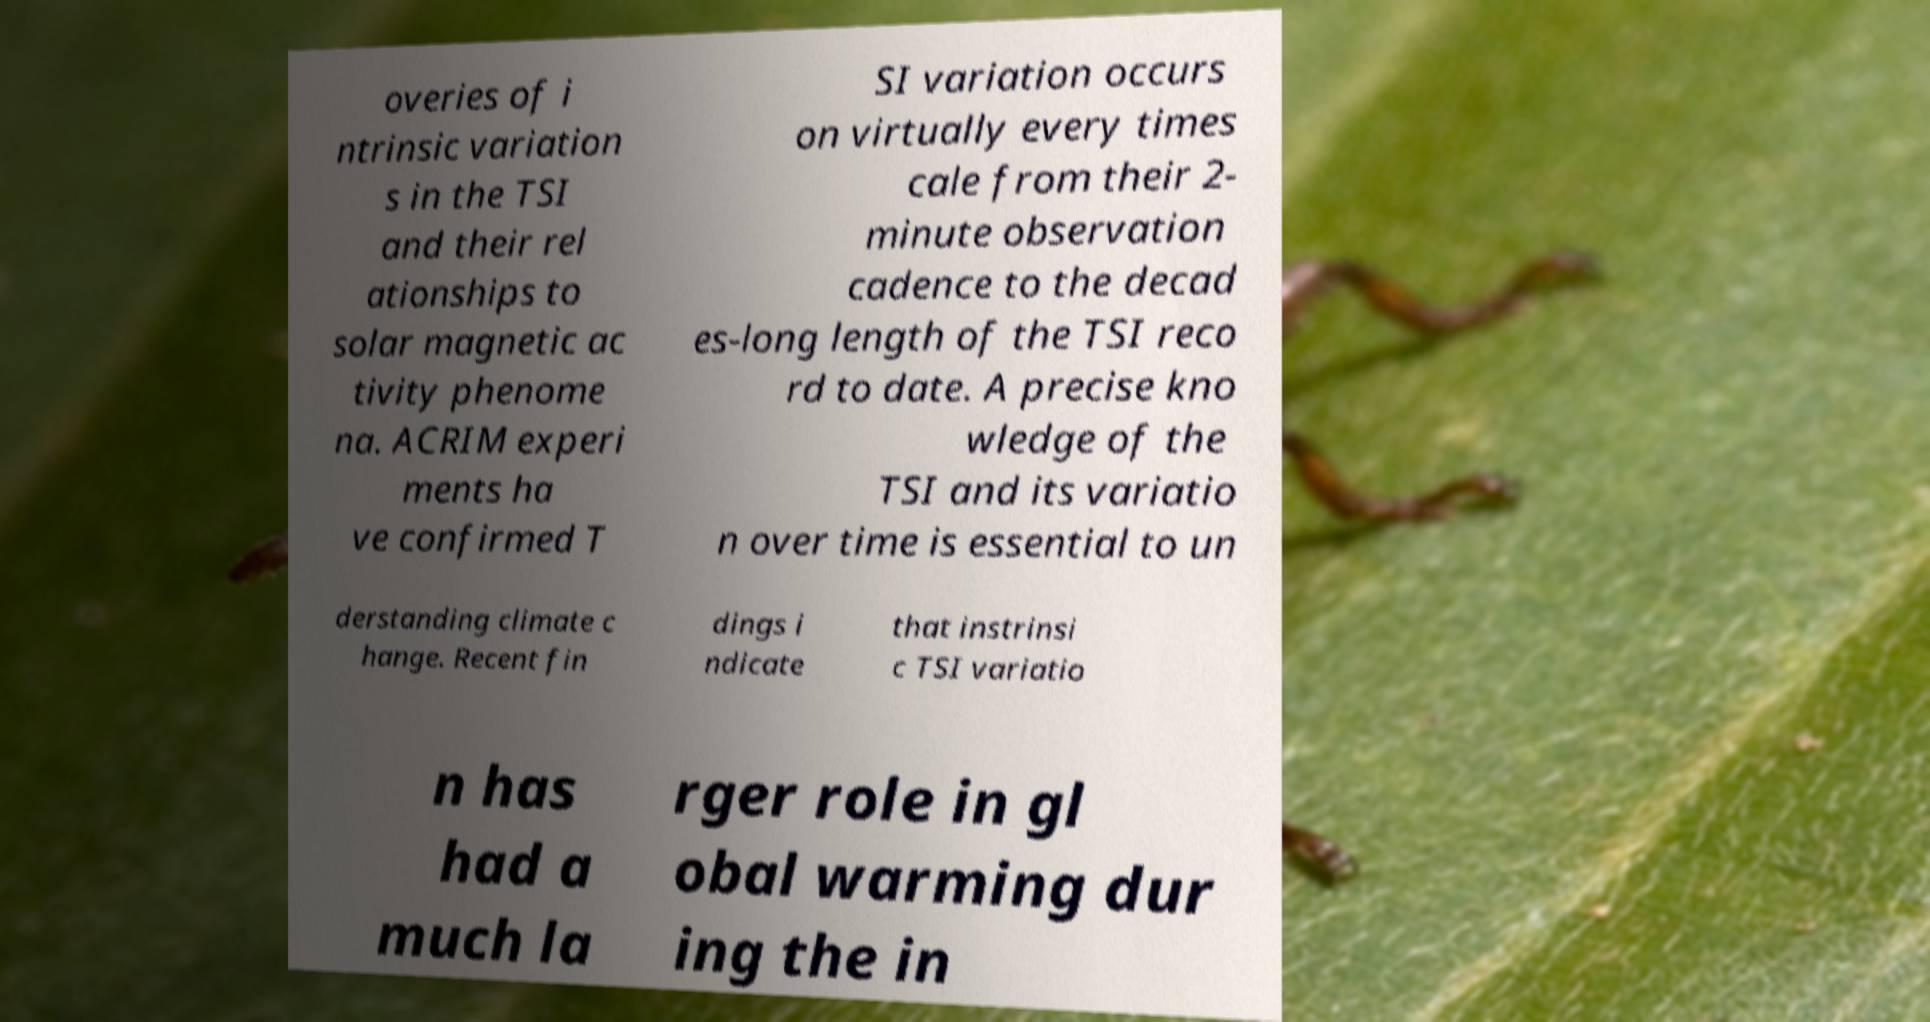Please identify and transcribe the text found in this image. overies of i ntrinsic variation s in the TSI and their rel ationships to solar magnetic ac tivity phenome na. ACRIM experi ments ha ve confirmed T SI variation occurs on virtually every times cale from their 2- minute observation cadence to the decad es-long length of the TSI reco rd to date. A precise kno wledge of the TSI and its variatio n over time is essential to un derstanding climate c hange. Recent fin dings i ndicate that instrinsi c TSI variatio n has had a much la rger role in gl obal warming dur ing the in 